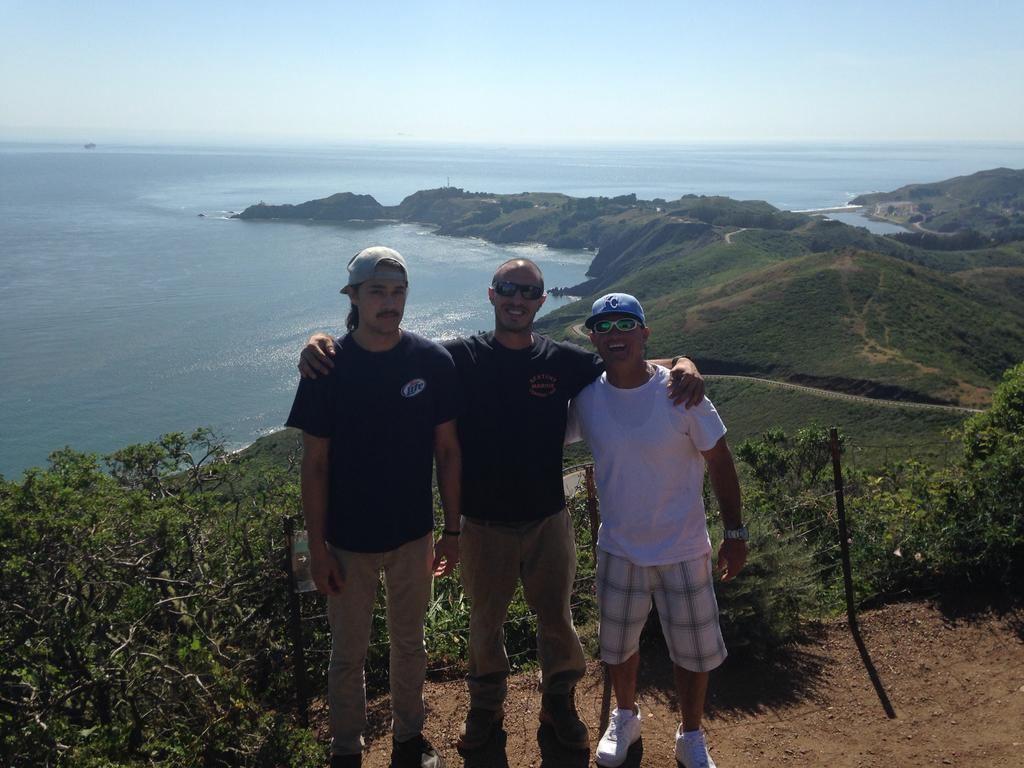How many people are in the image? There are three people standing on the ground in the image. What can be seen in the background of the image? There are trees, a fence, grass, rocks, water, and the sky visible in the background. What type of terrain is present in the background? The background features grass, rocks, and water, suggesting a natural setting. What type of prison can be seen in the background of the image? There is no prison present in the image; the background features trees, a fence, grass, rocks, water, and the sky. What color is the shirt worn by the person on the left in the image? The provided facts do not mention any clothing or colors, so it is impossible to determine the color of the shirt worn by the person on the left. 